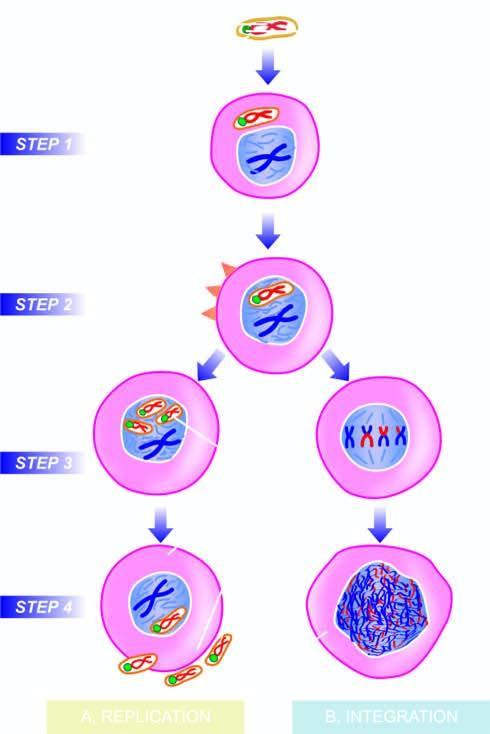s viral dna incorporated into the host nucleus?
Answer the question using a single word or phrase. Yes 